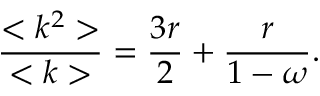<formula> <loc_0><loc_0><loc_500><loc_500>\frac { < k ^ { 2 } > } { < k > } = \frac { 3 r } { 2 } + \frac { r } { 1 - \omega } .</formula> 